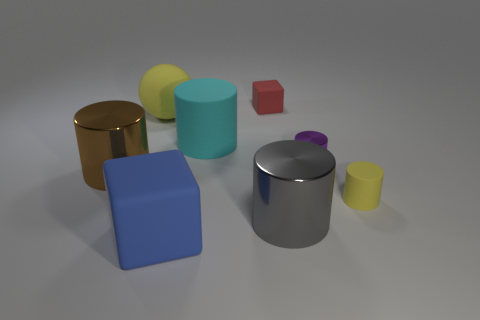Subtract 1 cylinders. How many cylinders are left? 4 Subtract all gray cylinders. How many cylinders are left? 4 Subtract all cyan matte cylinders. How many cylinders are left? 4 Subtract all red cylinders. Subtract all blue balls. How many cylinders are left? 5 Add 2 cyan matte things. How many objects exist? 10 Subtract all cubes. How many objects are left? 6 Subtract 0 cyan blocks. How many objects are left? 8 Subtract all small green balls. Subtract all matte cylinders. How many objects are left? 6 Add 4 big brown objects. How many big brown objects are left? 5 Add 1 small green cubes. How many small green cubes exist? 1 